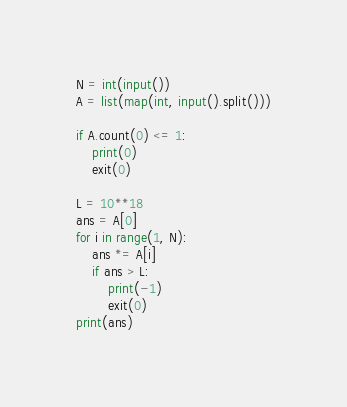Convert code to text. <code><loc_0><loc_0><loc_500><loc_500><_Python_>N = int(input())
A = list(map(int, input().split()))

if A.count(0) <= 1:
    print(0)
    exit(0)

L = 10**18
ans = A[0]
for i in range(1, N):
    ans *= A[i]
    if ans > L:
        print(-1)
        exit(0)
print(ans)
</code> 